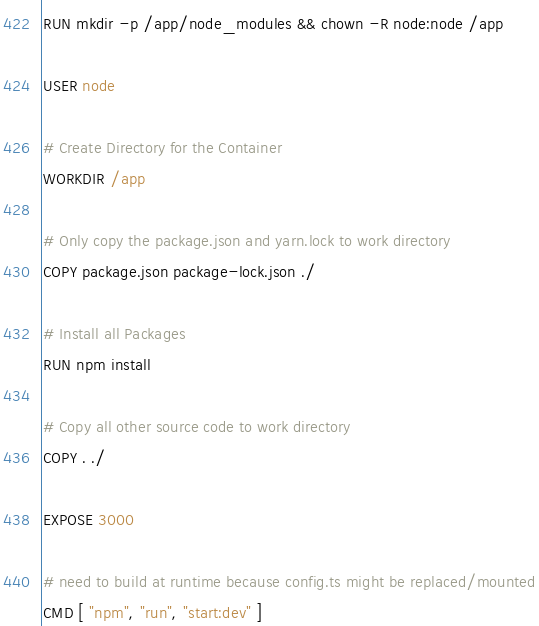<code> <loc_0><loc_0><loc_500><loc_500><_Dockerfile_>RUN mkdir -p /app/node_modules && chown -R node:node /app

USER node

# Create Directory for the Container
WORKDIR /app

# Only copy the package.json and yarn.lock to work directory
COPY package.json package-lock.json ./

# Install all Packages
RUN npm install

# Copy all other source code to work directory
COPY . ./

EXPOSE 3000

# need to build at runtime because config.ts might be replaced/mounted
CMD [ "npm", "run", "start:dev" ]
</code> 